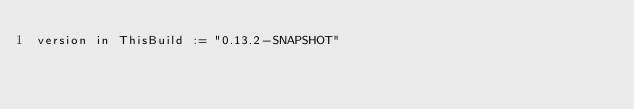<code> <loc_0><loc_0><loc_500><loc_500><_Scala_>version in ThisBuild := "0.13.2-SNAPSHOT"
</code> 